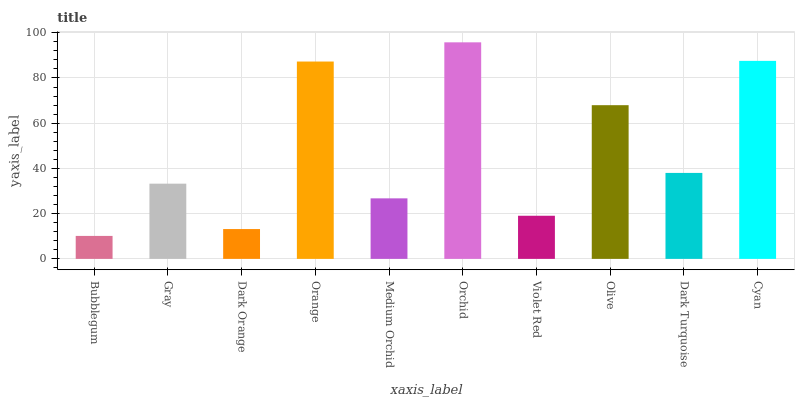Is Bubblegum the minimum?
Answer yes or no. Yes. Is Orchid the maximum?
Answer yes or no. Yes. Is Gray the minimum?
Answer yes or no. No. Is Gray the maximum?
Answer yes or no. No. Is Gray greater than Bubblegum?
Answer yes or no. Yes. Is Bubblegum less than Gray?
Answer yes or no. Yes. Is Bubblegum greater than Gray?
Answer yes or no. No. Is Gray less than Bubblegum?
Answer yes or no. No. Is Dark Turquoise the high median?
Answer yes or no. Yes. Is Gray the low median?
Answer yes or no. Yes. Is Medium Orchid the high median?
Answer yes or no. No. Is Olive the low median?
Answer yes or no. No. 